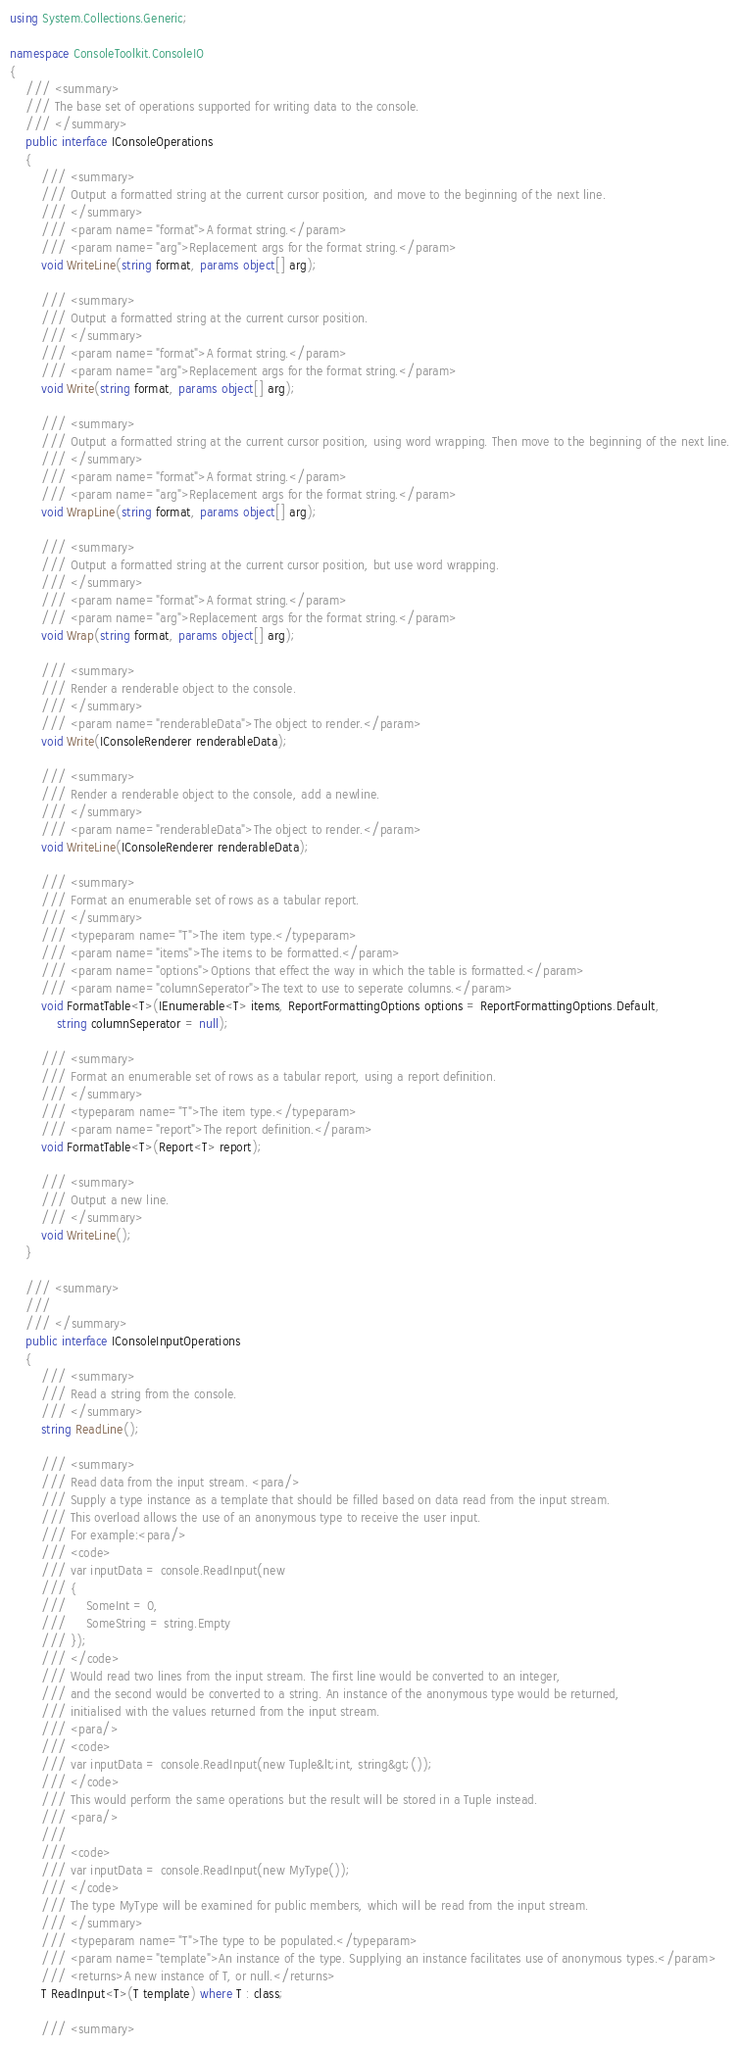<code> <loc_0><loc_0><loc_500><loc_500><_C#_>using System.Collections.Generic;

namespace ConsoleToolkit.ConsoleIO
{
    /// <summary>
    /// The base set of operations supported for writing data to the console.
    /// </summary>
    public interface IConsoleOperations
    {
        /// <summary>
        /// Output a formatted string at the current cursor position, and move to the beginning of the next line.
        /// </summary>
        /// <param name="format">A format string.</param>
        /// <param name="arg">Replacement args for the format string.</param>
        void WriteLine(string format, params object[] arg);

        /// <summary>
        /// Output a formatted string at the current cursor position.
        /// </summary>
        /// <param name="format">A format string.</param>
        /// <param name="arg">Replacement args for the format string.</param>
        void Write(string format, params object[] arg);

        /// <summary>
        /// Output a formatted string at the current cursor position, using word wrapping. Then move to the beginning of the next line.
        /// </summary>
        /// <param name="format">A format string.</param>
        /// <param name="arg">Replacement args for the format string.</param>
        void WrapLine(string format, params object[] arg);

        /// <summary>
        /// Output a formatted string at the current cursor position, but use word wrapping.
        /// </summary>
        /// <param name="format">A format string.</param>
        /// <param name="arg">Replacement args for the format string.</param>
        void Wrap(string format, params object[] arg);

        /// <summary>
        /// Render a renderable object to the console.
        /// </summary>
        /// <param name="renderableData">The object to render.</param>
        void Write(IConsoleRenderer renderableData);

        /// <summary>
        /// Render a renderable object to the console, add a newline.
        /// </summary>
        /// <param name="renderableData">The object to render.</param>
        void WriteLine(IConsoleRenderer renderableData);

        /// <summary>
        /// Format an enumerable set of rows as a tabular report.
        /// </summary>
        /// <typeparam name="T">The item type.</typeparam>
        /// <param name="items">The items to be formatted.</param>
        /// <param name="options">Options that effect the way in which the table is formatted.</param>
        /// <param name="columnSeperator">The text to use to seperate columns.</param>
        void FormatTable<T>(IEnumerable<T> items, ReportFormattingOptions options = ReportFormattingOptions.Default,
            string columnSeperator = null);

        /// <summary>
        /// Format an enumerable set of rows as a tabular report, using a report definition.
        /// </summary>
        /// <typeparam name="T">The item type.</typeparam>
        /// <param name="report">The report definition.</param>
        void FormatTable<T>(Report<T> report);

        /// <summary>
        /// Output a new line.
        /// </summary>
        void WriteLine();
    }

    /// <summary>
    /// 
    /// </summary>
    public interface IConsoleInputOperations
    {
        /// <summary>
        /// Read a string from the console.
        /// </summary>
        string ReadLine();

        /// <summary>
        /// Read data from the input stream. <para/>
        /// Supply a type instance as a template that should be filled based on data read from the input stream. 
        /// This overload allows the use of an anonymous type to receive the user input.
        /// For example:<para/>
        /// <code>
        /// var inputData = console.ReadInput(new 
        /// { 
        ///     SomeInt = 0, 
        ///     SomeString = string.Empty 
        /// });
        /// </code>
        /// Would read two lines from the input stream. The first line would be converted to an integer, 
        /// and the second would be converted to a string. An instance of the anonymous type would be returned,
        /// initialised with the values returned from the input stream.
        /// <para/>
        /// <code>
        /// var inputData = console.ReadInput(new Tuple&lt;int, string&gt;());
        /// </code>
        /// This would perform the same operations but the result will be stored in a Tuple instead.
        /// <para/>
        /// 
        /// <code>
        /// var inputData = console.ReadInput(new MyType());
        /// </code>
        /// The type MyType will be examined for public members, which will be read from the input stream.
        /// </summary>
        /// <typeparam name="T">The type to be populated.</typeparam>
        /// <param name="template">An instance of the type. Supplying an instance facilitates use of anonymous types.</param>
        /// <returns>A new instance of T, or null.</returns>
        T ReadInput<T>(T template) where T : class;

        /// <summary></code> 